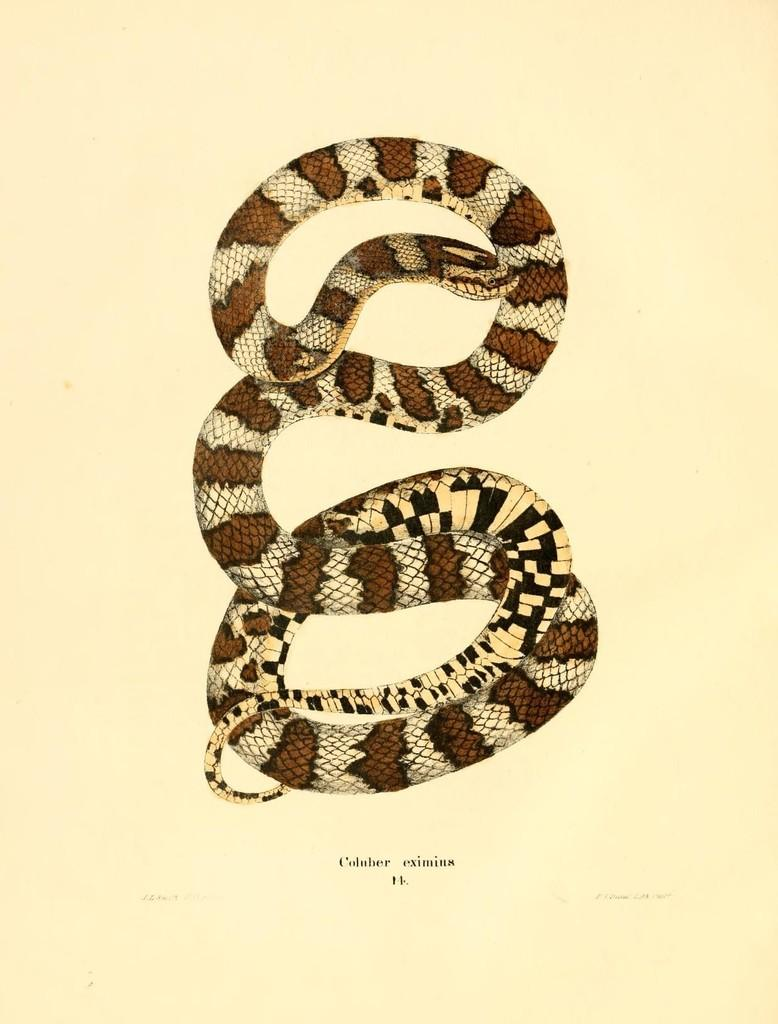What is depicted on the paper in the image? There is a snake picture on a paper. What else can be found on the paper besides the snake picture? There is text on the paper. What type of thread is being used to write the text on the paper? There is no thread present in the image; the text is likely written with a pen or pencil. 